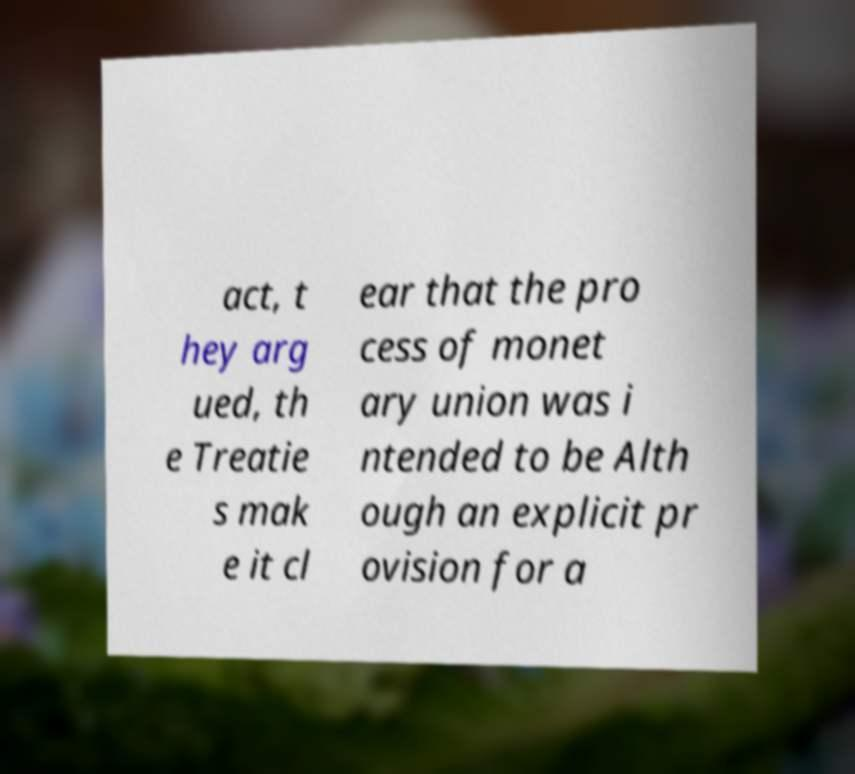Please read and relay the text visible in this image. What does it say? act, t hey arg ued, th e Treatie s mak e it cl ear that the pro cess of monet ary union was i ntended to be Alth ough an explicit pr ovision for a 